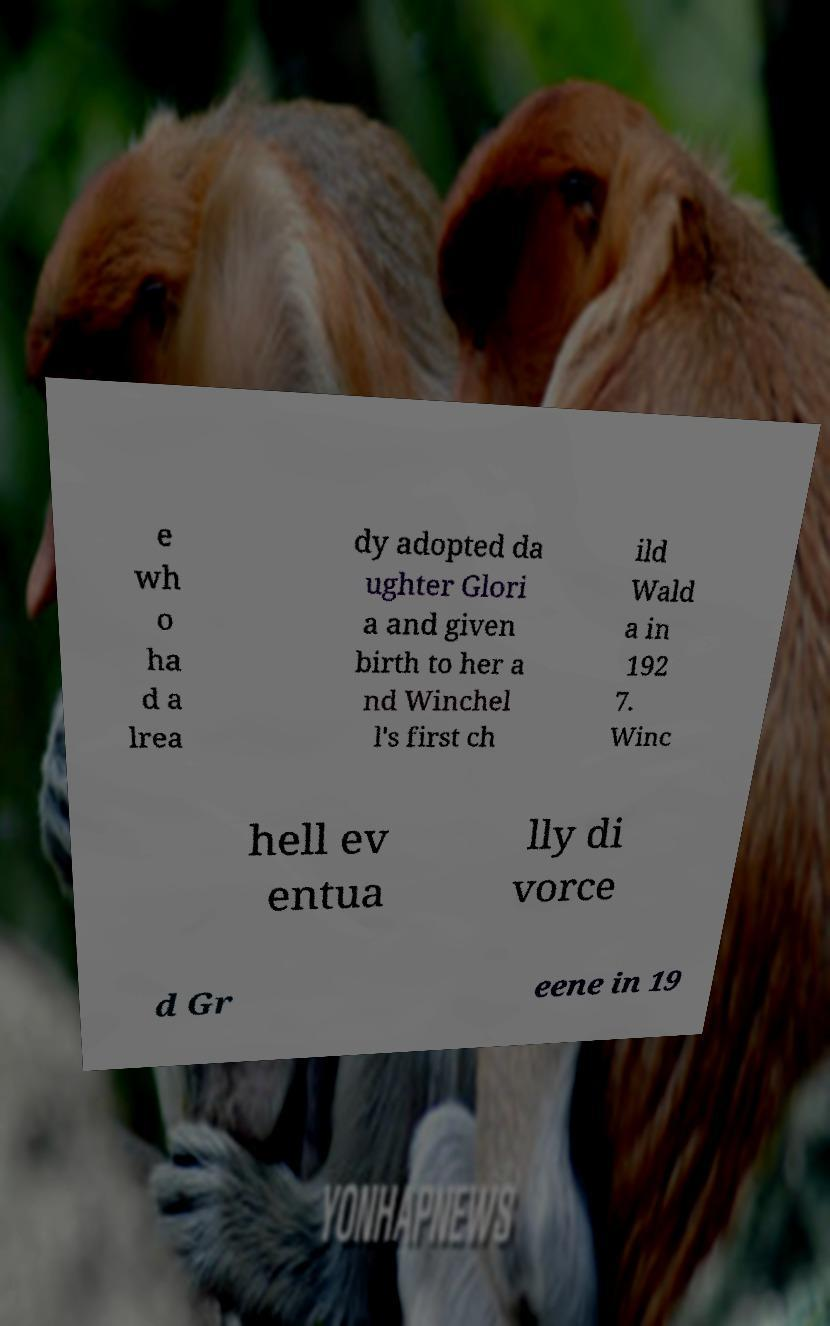For documentation purposes, I need the text within this image transcribed. Could you provide that? e wh o ha d a lrea dy adopted da ughter Glori a and given birth to her a nd Winchel l's first ch ild Wald a in 192 7. Winc hell ev entua lly di vorce d Gr eene in 19 